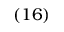Convert formula to latex. <formula><loc_0><loc_0><loc_500><loc_500>\left ( 1 6 \right )</formula> 